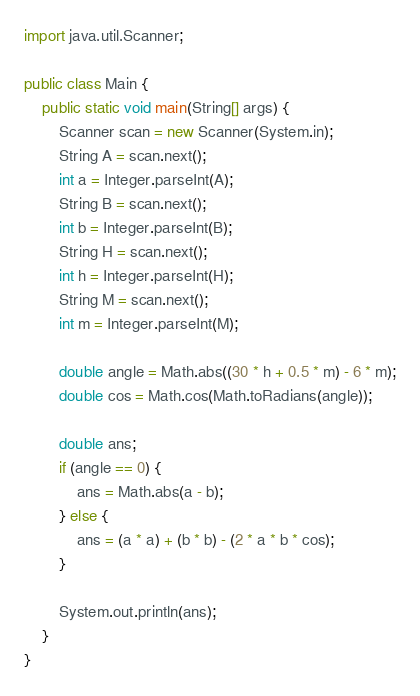<code> <loc_0><loc_0><loc_500><loc_500><_Java_>import java.util.Scanner;
 
public class Main {
    public static void main(String[] args) {
        Scanner scan = new Scanner(System.in);
        String A = scan.next();
        int a = Integer.parseInt(A);
        String B = scan.next();
        int b = Integer.parseInt(B);
        String H = scan.next();
        int h = Integer.parseInt(H);
        String M = scan.next();
        int m = Integer.parseInt(M);

        double angle = Math.abs((30 * h + 0.5 * m) - 6 * m);
        double cos = Math.cos(Math.toRadians(angle));

        double ans;
        if (angle == 0) {
            ans = Math.abs(a - b);
        } else {
            ans = (a * a) + (b * b) - (2 * a * b * cos);
        }

        System.out.println(ans);
    }
}

</code> 